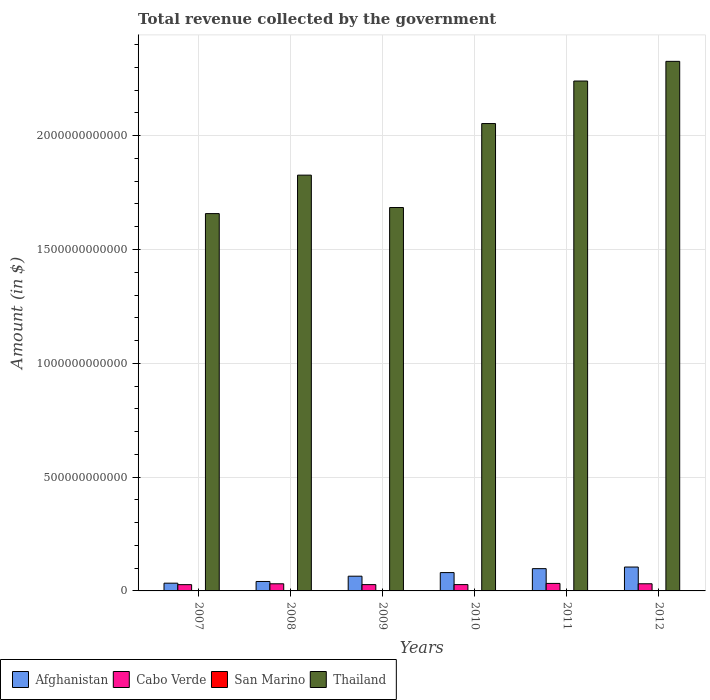How many different coloured bars are there?
Make the answer very short. 4. How many groups of bars are there?
Give a very brief answer. 6. What is the total revenue collected by the government in San Marino in 2008?
Offer a very short reply. 5.91e+08. Across all years, what is the maximum total revenue collected by the government in Thailand?
Give a very brief answer. 2.33e+12. Across all years, what is the minimum total revenue collected by the government in Thailand?
Provide a short and direct response. 1.66e+12. In which year was the total revenue collected by the government in Afghanistan maximum?
Your response must be concise. 2012. What is the total total revenue collected by the government in Thailand in the graph?
Keep it short and to the point. 1.18e+13. What is the difference between the total revenue collected by the government in San Marino in 2007 and that in 2011?
Your response must be concise. 3.65e+07. What is the difference between the total revenue collected by the government in Thailand in 2010 and the total revenue collected by the government in Afghanistan in 2012?
Offer a terse response. 1.95e+12. What is the average total revenue collected by the government in San Marino per year?
Your response must be concise. 5.53e+08. In the year 2012, what is the difference between the total revenue collected by the government in Thailand and total revenue collected by the government in San Marino?
Keep it short and to the point. 2.33e+12. In how many years, is the total revenue collected by the government in San Marino greater than 1000000000000 $?
Make the answer very short. 0. What is the ratio of the total revenue collected by the government in Cabo Verde in 2008 to that in 2012?
Give a very brief answer. 1. Is the total revenue collected by the government in Afghanistan in 2007 less than that in 2008?
Keep it short and to the point. Yes. What is the difference between the highest and the second highest total revenue collected by the government in Cabo Verde?
Provide a succinct answer. 1.59e+09. What is the difference between the highest and the lowest total revenue collected by the government in Cabo Verde?
Provide a short and direct response. 5.41e+09. In how many years, is the total revenue collected by the government in Thailand greater than the average total revenue collected by the government in Thailand taken over all years?
Offer a very short reply. 3. Is it the case that in every year, the sum of the total revenue collected by the government in Afghanistan and total revenue collected by the government in Thailand is greater than the sum of total revenue collected by the government in Cabo Verde and total revenue collected by the government in San Marino?
Your answer should be very brief. Yes. What does the 1st bar from the left in 2007 represents?
Offer a very short reply. Afghanistan. What does the 3rd bar from the right in 2008 represents?
Your answer should be compact. Cabo Verde. Is it the case that in every year, the sum of the total revenue collected by the government in San Marino and total revenue collected by the government in Thailand is greater than the total revenue collected by the government in Afghanistan?
Give a very brief answer. Yes. How many years are there in the graph?
Offer a very short reply. 6. What is the difference between two consecutive major ticks on the Y-axis?
Give a very brief answer. 5.00e+11. Are the values on the major ticks of Y-axis written in scientific E-notation?
Make the answer very short. No. Does the graph contain any zero values?
Ensure brevity in your answer.  No. Does the graph contain grids?
Your answer should be very brief. Yes. How many legend labels are there?
Your response must be concise. 4. How are the legend labels stacked?
Ensure brevity in your answer.  Horizontal. What is the title of the graph?
Make the answer very short. Total revenue collected by the government. What is the label or title of the X-axis?
Give a very brief answer. Years. What is the label or title of the Y-axis?
Offer a very short reply. Amount (in $). What is the Amount (in $) of Afghanistan in 2007?
Your response must be concise. 3.40e+1. What is the Amount (in $) of Cabo Verde in 2007?
Give a very brief answer. 2.75e+1. What is the Amount (in $) of San Marino in 2007?
Your answer should be compact. 5.60e+08. What is the Amount (in $) of Thailand in 2007?
Provide a succinct answer. 1.66e+12. What is the Amount (in $) of Afghanistan in 2008?
Make the answer very short. 4.15e+1. What is the Amount (in $) in Cabo Verde in 2008?
Your answer should be very brief. 3.13e+1. What is the Amount (in $) in San Marino in 2008?
Ensure brevity in your answer.  5.91e+08. What is the Amount (in $) in Thailand in 2008?
Offer a terse response. 1.83e+12. What is the Amount (in $) of Afghanistan in 2009?
Give a very brief answer. 6.47e+1. What is the Amount (in $) in Cabo Verde in 2009?
Offer a terse response. 2.77e+1. What is the Amount (in $) in San Marino in 2009?
Give a very brief answer. 5.62e+08. What is the Amount (in $) of Thailand in 2009?
Make the answer very short. 1.68e+12. What is the Amount (in $) in Afghanistan in 2010?
Keep it short and to the point. 8.06e+1. What is the Amount (in $) in Cabo Verde in 2010?
Offer a terse response. 2.78e+1. What is the Amount (in $) of San Marino in 2010?
Provide a succinct answer. 5.31e+08. What is the Amount (in $) of Thailand in 2010?
Offer a very short reply. 2.05e+12. What is the Amount (in $) of Afghanistan in 2011?
Your answer should be compact. 9.79e+1. What is the Amount (in $) of Cabo Verde in 2011?
Offer a terse response. 3.30e+1. What is the Amount (in $) in San Marino in 2011?
Your response must be concise. 5.23e+08. What is the Amount (in $) in Thailand in 2011?
Your answer should be compact. 2.24e+12. What is the Amount (in $) of Afghanistan in 2012?
Provide a short and direct response. 1.05e+11. What is the Amount (in $) of Cabo Verde in 2012?
Ensure brevity in your answer.  3.14e+1. What is the Amount (in $) of San Marino in 2012?
Your response must be concise. 5.53e+08. What is the Amount (in $) in Thailand in 2012?
Offer a very short reply. 2.33e+12. Across all years, what is the maximum Amount (in $) in Afghanistan?
Ensure brevity in your answer.  1.05e+11. Across all years, what is the maximum Amount (in $) in Cabo Verde?
Provide a short and direct response. 3.30e+1. Across all years, what is the maximum Amount (in $) of San Marino?
Make the answer very short. 5.91e+08. Across all years, what is the maximum Amount (in $) in Thailand?
Your response must be concise. 2.33e+12. Across all years, what is the minimum Amount (in $) in Afghanistan?
Provide a short and direct response. 3.40e+1. Across all years, what is the minimum Amount (in $) of Cabo Verde?
Offer a terse response. 2.75e+1. Across all years, what is the minimum Amount (in $) in San Marino?
Make the answer very short. 5.23e+08. Across all years, what is the minimum Amount (in $) of Thailand?
Provide a short and direct response. 1.66e+12. What is the total Amount (in $) of Afghanistan in the graph?
Provide a succinct answer. 4.24e+11. What is the total Amount (in $) of Cabo Verde in the graph?
Give a very brief answer. 1.79e+11. What is the total Amount (in $) in San Marino in the graph?
Provide a succinct answer. 3.32e+09. What is the total Amount (in $) in Thailand in the graph?
Keep it short and to the point. 1.18e+13. What is the difference between the Amount (in $) of Afghanistan in 2007 and that in 2008?
Provide a succinct answer. -7.45e+09. What is the difference between the Amount (in $) of Cabo Verde in 2007 and that in 2008?
Your answer should be compact. -3.78e+09. What is the difference between the Amount (in $) of San Marino in 2007 and that in 2008?
Give a very brief answer. -3.11e+07. What is the difference between the Amount (in $) of Thailand in 2007 and that in 2008?
Offer a very short reply. -1.69e+11. What is the difference between the Amount (in $) in Afghanistan in 2007 and that in 2009?
Offer a very short reply. -3.07e+1. What is the difference between the Amount (in $) of Cabo Verde in 2007 and that in 2009?
Your answer should be very brief. -1.49e+08. What is the difference between the Amount (in $) of San Marino in 2007 and that in 2009?
Ensure brevity in your answer.  -2.35e+06. What is the difference between the Amount (in $) of Thailand in 2007 and that in 2009?
Provide a short and direct response. -2.67e+1. What is the difference between the Amount (in $) of Afghanistan in 2007 and that in 2010?
Provide a succinct answer. -4.65e+1. What is the difference between the Amount (in $) of Cabo Verde in 2007 and that in 2010?
Provide a short and direct response. -2.30e+08. What is the difference between the Amount (in $) in San Marino in 2007 and that in 2010?
Your response must be concise. 2.91e+07. What is the difference between the Amount (in $) in Thailand in 2007 and that in 2010?
Give a very brief answer. -3.96e+11. What is the difference between the Amount (in $) in Afghanistan in 2007 and that in 2011?
Offer a very short reply. -6.39e+1. What is the difference between the Amount (in $) in Cabo Verde in 2007 and that in 2011?
Ensure brevity in your answer.  -5.41e+09. What is the difference between the Amount (in $) of San Marino in 2007 and that in 2011?
Give a very brief answer. 3.65e+07. What is the difference between the Amount (in $) of Thailand in 2007 and that in 2011?
Your response must be concise. -5.82e+11. What is the difference between the Amount (in $) in Afghanistan in 2007 and that in 2012?
Make the answer very short. -7.09e+1. What is the difference between the Amount (in $) in Cabo Verde in 2007 and that in 2012?
Offer a very short reply. -3.83e+09. What is the difference between the Amount (in $) of San Marino in 2007 and that in 2012?
Keep it short and to the point. 6.55e+06. What is the difference between the Amount (in $) in Thailand in 2007 and that in 2012?
Offer a very short reply. -6.69e+11. What is the difference between the Amount (in $) in Afghanistan in 2008 and that in 2009?
Provide a short and direct response. -2.32e+1. What is the difference between the Amount (in $) in Cabo Verde in 2008 and that in 2009?
Your response must be concise. 3.63e+09. What is the difference between the Amount (in $) in San Marino in 2008 and that in 2009?
Your answer should be compact. 2.87e+07. What is the difference between the Amount (in $) of Thailand in 2008 and that in 2009?
Give a very brief answer. 1.42e+11. What is the difference between the Amount (in $) of Afghanistan in 2008 and that in 2010?
Make the answer very short. -3.91e+1. What is the difference between the Amount (in $) of Cabo Verde in 2008 and that in 2010?
Your answer should be very brief. 3.55e+09. What is the difference between the Amount (in $) in San Marino in 2008 and that in 2010?
Offer a very short reply. 6.02e+07. What is the difference between the Amount (in $) in Thailand in 2008 and that in 2010?
Your response must be concise. -2.27e+11. What is the difference between the Amount (in $) in Afghanistan in 2008 and that in 2011?
Your response must be concise. -5.64e+1. What is the difference between the Amount (in $) in Cabo Verde in 2008 and that in 2011?
Offer a terse response. -1.63e+09. What is the difference between the Amount (in $) of San Marino in 2008 and that in 2011?
Your answer should be very brief. 6.76e+07. What is the difference between the Amount (in $) in Thailand in 2008 and that in 2011?
Make the answer very short. -4.13e+11. What is the difference between the Amount (in $) in Afghanistan in 2008 and that in 2012?
Offer a terse response. -6.35e+1. What is the difference between the Amount (in $) of Cabo Verde in 2008 and that in 2012?
Your answer should be compact. -4.40e+07. What is the difference between the Amount (in $) of San Marino in 2008 and that in 2012?
Offer a very short reply. 3.76e+07. What is the difference between the Amount (in $) in Thailand in 2008 and that in 2012?
Your answer should be compact. -5.00e+11. What is the difference between the Amount (in $) of Afghanistan in 2009 and that in 2010?
Your answer should be very brief. -1.59e+1. What is the difference between the Amount (in $) in Cabo Verde in 2009 and that in 2010?
Your answer should be very brief. -8.03e+07. What is the difference between the Amount (in $) in San Marino in 2009 and that in 2010?
Offer a terse response. 3.15e+07. What is the difference between the Amount (in $) in Thailand in 2009 and that in 2010?
Provide a short and direct response. -3.69e+11. What is the difference between the Amount (in $) in Afghanistan in 2009 and that in 2011?
Your answer should be compact. -3.32e+1. What is the difference between the Amount (in $) of Cabo Verde in 2009 and that in 2011?
Give a very brief answer. -5.26e+09. What is the difference between the Amount (in $) of San Marino in 2009 and that in 2011?
Your answer should be compact. 3.89e+07. What is the difference between the Amount (in $) in Thailand in 2009 and that in 2011?
Provide a short and direct response. -5.56e+11. What is the difference between the Amount (in $) in Afghanistan in 2009 and that in 2012?
Offer a very short reply. -4.03e+1. What is the difference between the Amount (in $) of Cabo Verde in 2009 and that in 2012?
Provide a succinct answer. -3.68e+09. What is the difference between the Amount (in $) of San Marino in 2009 and that in 2012?
Your answer should be compact. 8.90e+06. What is the difference between the Amount (in $) of Thailand in 2009 and that in 2012?
Give a very brief answer. -6.42e+11. What is the difference between the Amount (in $) in Afghanistan in 2010 and that in 2011?
Give a very brief answer. -1.73e+1. What is the difference between the Amount (in $) of Cabo Verde in 2010 and that in 2011?
Your answer should be very brief. -5.18e+09. What is the difference between the Amount (in $) in San Marino in 2010 and that in 2011?
Your answer should be compact. 7.36e+06. What is the difference between the Amount (in $) in Thailand in 2010 and that in 2011?
Keep it short and to the point. -1.87e+11. What is the difference between the Amount (in $) of Afghanistan in 2010 and that in 2012?
Offer a terse response. -2.44e+1. What is the difference between the Amount (in $) in Cabo Verde in 2010 and that in 2012?
Ensure brevity in your answer.  -3.60e+09. What is the difference between the Amount (in $) in San Marino in 2010 and that in 2012?
Your answer should be very brief. -2.26e+07. What is the difference between the Amount (in $) in Thailand in 2010 and that in 2012?
Your answer should be very brief. -2.73e+11. What is the difference between the Amount (in $) of Afghanistan in 2011 and that in 2012?
Offer a terse response. -7.07e+09. What is the difference between the Amount (in $) in Cabo Verde in 2011 and that in 2012?
Give a very brief answer. 1.59e+09. What is the difference between the Amount (in $) of San Marino in 2011 and that in 2012?
Give a very brief answer. -3.00e+07. What is the difference between the Amount (in $) in Thailand in 2011 and that in 2012?
Your answer should be very brief. -8.64e+1. What is the difference between the Amount (in $) in Afghanistan in 2007 and the Amount (in $) in Cabo Verde in 2008?
Offer a terse response. 2.70e+09. What is the difference between the Amount (in $) in Afghanistan in 2007 and the Amount (in $) in San Marino in 2008?
Offer a terse response. 3.34e+1. What is the difference between the Amount (in $) in Afghanistan in 2007 and the Amount (in $) in Thailand in 2008?
Make the answer very short. -1.79e+12. What is the difference between the Amount (in $) of Cabo Verde in 2007 and the Amount (in $) of San Marino in 2008?
Your answer should be compact. 2.70e+1. What is the difference between the Amount (in $) of Cabo Verde in 2007 and the Amount (in $) of Thailand in 2008?
Provide a succinct answer. -1.80e+12. What is the difference between the Amount (in $) in San Marino in 2007 and the Amount (in $) in Thailand in 2008?
Offer a terse response. -1.83e+12. What is the difference between the Amount (in $) of Afghanistan in 2007 and the Amount (in $) of Cabo Verde in 2009?
Your answer should be very brief. 6.33e+09. What is the difference between the Amount (in $) of Afghanistan in 2007 and the Amount (in $) of San Marino in 2009?
Offer a terse response. 3.35e+1. What is the difference between the Amount (in $) of Afghanistan in 2007 and the Amount (in $) of Thailand in 2009?
Your answer should be very brief. -1.65e+12. What is the difference between the Amount (in $) of Cabo Verde in 2007 and the Amount (in $) of San Marino in 2009?
Offer a terse response. 2.70e+1. What is the difference between the Amount (in $) in Cabo Verde in 2007 and the Amount (in $) in Thailand in 2009?
Your answer should be very brief. -1.66e+12. What is the difference between the Amount (in $) of San Marino in 2007 and the Amount (in $) of Thailand in 2009?
Provide a succinct answer. -1.68e+12. What is the difference between the Amount (in $) of Afghanistan in 2007 and the Amount (in $) of Cabo Verde in 2010?
Offer a very short reply. 6.25e+09. What is the difference between the Amount (in $) of Afghanistan in 2007 and the Amount (in $) of San Marino in 2010?
Your answer should be compact. 3.35e+1. What is the difference between the Amount (in $) of Afghanistan in 2007 and the Amount (in $) of Thailand in 2010?
Your response must be concise. -2.02e+12. What is the difference between the Amount (in $) of Cabo Verde in 2007 and the Amount (in $) of San Marino in 2010?
Give a very brief answer. 2.70e+1. What is the difference between the Amount (in $) in Cabo Verde in 2007 and the Amount (in $) in Thailand in 2010?
Offer a terse response. -2.03e+12. What is the difference between the Amount (in $) in San Marino in 2007 and the Amount (in $) in Thailand in 2010?
Offer a terse response. -2.05e+12. What is the difference between the Amount (in $) of Afghanistan in 2007 and the Amount (in $) of Cabo Verde in 2011?
Your answer should be very brief. 1.07e+09. What is the difference between the Amount (in $) in Afghanistan in 2007 and the Amount (in $) in San Marino in 2011?
Give a very brief answer. 3.35e+1. What is the difference between the Amount (in $) of Afghanistan in 2007 and the Amount (in $) of Thailand in 2011?
Your answer should be very brief. -2.21e+12. What is the difference between the Amount (in $) of Cabo Verde in 2007 and the Amount (in $) of San Marino in 2011?
Offer a terse response. 2.70e+1. What is the difference between the Amount (in $) of Cabo Verde in 2007 and the Amount (in $) of Thailand in 2011?
Provide a short and direct response. -2.21e+12. What is the difference between the Amount (in $) of San Marino in 2007 and the Amount (in $) of Thailand in 2011?
Your response must be concise. -2.24e+12. What is the difference between the Amount (in $) in Afghanistan in 2007 and the Amount (in $) in Cabo Verde in 2012?
Provide a succinct answer. 2.65e+09. What is the difference between the Amount (in $) in Afghanistan in 2007 and the Amount (in $) in San Marino in 2012?
Keep it short and to the point. 3.35e+1. What is the difference between the Amount (in $) in Afghanistan in 2007 and the Amount (in $) in Thailand in 2012?
Offer a terse response. -2.29e+12. What is the difference between the Amount (in $) of Cabo Verde in 2007 and the Amount (in $) of San Marino in 2012?
Your answer should be very brief. 2.70e+1. What is the difference between the Amount (in $) in Cabo Verde in 2007 and the Amount (in $) in Thailand in 2012?
Provide a short and direct response. -2.30e+12. What is the difference between the Amount (in $) in San Marino in 2007 and the Amount (in $) in Thailand in 2012?
Keep it short and to the point. -2.33e+12. What is the difference between the Amount (in $) in Afghanistan in 2008 and the Amount (in $) in Cabo Verde in 2009?
Make the answer very short. 1.38e+1. What is the difference between the Amount (in $) in Afghanistan in 2008 and the Amount (in $) in San Marino in 2009?
Your answer should be very brief. 4.09e+1. What is the difference between the Amount (in $) of Afghanistan in 2008 and the Amount (in $) of Thailand in 2009?
Ensure brevity in your answer.  -1.64e+12. What is the difference between the Amount (in $) in Cabo Verde in 2008 and the Amount (in $) in San Marino in 2009?
Provide a short and direct response. 3.08e+1. What is the difference between the Amount (in $) of Cabo Verde in 2008 and the Amount (in $) of Thailand in 2009?
Keep it short and to the point. -1.65e+12. What is the difference between the Amount (in $) in San Marino in 2008 and the Amount (in $) in Thailand in 2009?
Your answer should be compact. -1.68e+12. What is the difference between the Amount (in $) of Afghanistan in 2008 and the Amount (in $) of Cabo Verde in 2010?
Give a very brief answer. 1.37e+1. What is the difference between the Amount (in $) in Afghanistan in 2008 and the Amount (in $) in San Marino in 2010?
Keep it short and to the point. 4.09e+1. What is the difference between the Amount (in $) of Afghanistan in 2008 and the Amount (in $) of Thailand in 2010?
Provide a short and direct response. -2.01e+12. What is the difference between the Amount (in $) in Cabo Verde in 2008 and the Amount (in $) in San Marino in 2010?
Your answer should be compact. 3.08e+1. What is the difference between the Amount (in $) in Cabo Verde in 2008 and the Amount (in $) in Thailand in 2010?
Make the answer very short. -2.02e+12. What is the difference between the Amount (in $) in San Marino in 2008 and the Amount (in $) in Thailand in 2010?
Your answer should be compact. -2.05e+12. What is the difference between the Amount (in $) of Afghanistan in 2008 and the Amount (in $) of Cabo Verde in 2011?
Provide a succinct answer. 8.52e+09. What is the difference between the Amount (in $) of Afghanistan in 2008 and the Amount (in $) of San Marino in 2011?
Provide a succinct answer. 4.10e+1. What is the difference between the Amount (in $) in Afghanistan in 2008 and the Amount (in $) in Thailand in 2011?
Offer a terse response. -2.20e+12. What is the difference between the Amount (in $) in Cabo Verde in 2008 and the Amount (in $) in San Marino in 2011?
Give a very brief answer. 3.08e+1. What is the difference between the Amount (in $) of Cabo Verde in 2008 and the Amount (in $) of Thailand in 2011?
Offer a very short reply. -2.21e+12. What is the difference between the Amount (in $) of San Marino in 2008 and the Amount (in $) of Thailand in 2011?
Offer a very short reply. -2.24e+12. What is the difference between the Amount (in $) of Afghanistan in 2008 and the Amount (in $) of Cabo Verde in 2012?
Offer a very short reply. 1.01e+1. What is the difference between the Amount (in $) of Afghanistan in 2008 and the Amount (in $) of San Marino in 2012?
Offer a very short reply. 4.09e+1. What is the difference between the Amount (in $) of Afghanistan in 2008 and the Amount (in $) of Thailand in 2012?
Your answer should be very brief. -2.29e+12. What is the difference between the Amount (in $) of Cabo Verde in 2008 and the Amount (in $) of San Marino in 2012?
Ensure brevity in your answer.  3.08e+1. What is the difference between the Amount (in $) in Cabo Verde in 2008 and the Amount (in $) in Thailand in 2012?
Ensure brevity in your answer.  -2.30e+12. What is the difference between the Amount (in $) of San Marino in 2008 and the Amount (in $) of Thailand in 2012?
Your response must be concise. -2.33e+12. What is the difference between the Amount (in $) in Afghanistan in 2009 and the Amount (in $) in Cabo Verde in 2010?
Give a very brief answer. 3.69e+1. What is the difference between the Amount (in $) in Afghanistan in 2009 and the Amount (in $) in San Marino in 2010?
Your answer should be compact. 6.42e+1. What is the difference between the Amount (in $) of Afghanistan in 2009 and the Amount (in $) of Thailand in 2010?
Ensure brevity in your answer.  -1.99e+12. What is the difference between the Amount (in $) of Cabo Verde in 2009 and the Amount (in $) of San Marino in 2010?
Your answer should be compact. 2.72e+1. What is the difference between the Amount (in $) in Cabo Verde in 2009 and the Amount (in $) in Thailand in 2010?
Give a very brief answer. -2.03e+12. What is the difference between the Amount (in $) in San Marino in 2009 and the Amount (in $) in Thailand in 2010?
Give a very brief answer. -2.05e+12. What is the difference between the Amount (in $) of Afghanistan in 2009 and the Amount (in $) of Cabo Verde in 2011?
Keep it short and to the point. 3.17e+1. What is the difference between the Amount (in $) in Afghanistan in 2009 and the Amount (in $) in San Marino in 2011?
Your answer should be compact. 6.42e+1. What is the difference between the Amount (in $) in Afghanistan in 2009 and the Amount (in $) in Thailand in 2011?
Keep it short and to the point. -2.18e+12. What is the difference between the Amount (in $) in Cabo Verde in 2009 and the Amount (in $) in San Marino in 2011?
Provide a succinct answer. 2.72e+1. What is the difference between the Amount (in $) in Cabo Verde in 2009 and the Amount (in $) in Thailand in 2011?
Provide a succinct answer. -2.21e+12. What is the difference between the Amount (in $) of San Marino in 2009 and the Amount (in $) of Thailand in 2011?
Ensure brevity in your answer.  -2.24e+12. What is the difference between the Amount (in $) of Afghanistan in 2009 and the Amount (in $) of Cabo Verde in 2012?
Keep it short and to the point. 3.33e+1. What is the difference between the Amount (in $) in Afghanistan in 2009 and the Amount (in $) in San Marino in 2012?
Offer a terse response. 6.41e+1. What is the difference between the Amount (in $) in Afghanistan in 2009 and the Amount (in $) in Thailand in 2012?
Your answer should be compact. -2.26e+12. What is the difference between the Amount (in $) of Cabo Verde in 2009 and the Amount (in $) of San Marino in 2012?
Give a very brief answer. 2.71e+1. What is the difference between the Amount (in $) in Cabo Verde in 2009 and the Amount (in $) in Thailand in 2012?
Keep it short and to the point. -2.30e+12. What is the difference between the Amount (in $) in San Marino in 2009 and the Amount (in $) in Thailand in 2012?
Your answer should be compact. -2.33e+12. What is the difference between the Amount (in $) of Afghanistan in 2010 and the Amount (in $) of Cabo Verde in 2011?
Your answer should be compact. 4.76e+1. What is the difference between the Amount (in $) in Afghanistan in 2010 and the Amount (in $) in San Marino in 2011?
Make the answer very short. 8.00e+1. What is the difference between the Amount (in $) in Afghanistan in 2010 and the Amount (in $) in Thailand in 2011?
Offer a terse response. -2.16e+12. What is the difference between the Amount (in $) of Cabo Verde in 2010 and the Amount (in $) of San Marino in 2011?
Ensure brevity in your answer.  2.72e+1. What is the difference between the Amount (in $) in Cabo Verde in 2010 and the Amount (in $) in Thailand in 2011?
Make the answer very short. -2.21e+12. What is the difference between the Amount (in $) of San Marino in 2010 and the Amount (in $) of Thailand in 2011?
Provide a succinct answer. -2.24e+12. What is the difference between the Amount (in $) in Afghanistan in 2010 and the Amount (in $) in Cabo Verde in 2012?
Your answer should be very brief. 4.92e+1. What is the difference between the Amount (in $) of Afghanistan in 2010 and the Amount (in $) of San Marino in 2012?
Provide a succinct answer. 8.00e+1. What is the difference between the Amount (in $) in Afghanistan in 2010 and the Amount (in $) in Thailand in 2012?
Ensure brevity in your answer.  -2.25e+12. What is the difference between the Amount (in $) of Cabo Verde in 2010 and the Amount (in $) of San Marino in 2012?
Keep it short and to the point. 2.72e+1. What is the difference between the Amount (in $) in Cabo Verde in 2010 and the Amount (in $) in Thailand in 2012?
Your response must be concise. -2.30e+12. What is the difference between the Amount (in $) of San Marino in 2010 and the Amount (in $) of Thailand in 2012?
Your answer should be compact. -2.33e+12. What is the difference between the Amount (in $) in Afghanistan in 2011 and the Amount (in $) in Cabo Verde in 2012?
Provide a short and direct response. 6.65e+1. What is the difference between the Amount (in $) in Afghanistan in 2011 and the Amount (in $) in San Marino in 2012?
Keep it short and to the point. 9.73e+1. What is the difference between the Amount (in $) in Afghanistan in 2011 and the Amount (in $) in Thailand in 2012?
Your answer should be compact. -2.23e+12. What is the difference between the Amount (in $) of Cabo Verde in 2011 and the Amount (in $) of San Marino in 2012?
Your answer should be very brief. 3.24e+1. What is the difference between the Amount (in $) in Cabo Verde in 2011 and the Amount (in $) in Thailand in 2012?
Offer a very short reply. -2.29e+12. What is the difference between the Amount (in $) in San Marino in 2011 and the Amount (in $) in Thailand in 2012?
Offer a very short reply. -2.33e+12. What is the average Amount (in $) of Afghanistan per year?
Your answer should be compact. 7.06e+1. What is the average Amount (in $) in Cabo Verde per year?
Your answer should be compact. 2.98e+1. What is the average Amount (in $) in San Marino per year?
Provide a succinct answer. 5.53e+08. What is the average Amount (in $) in Thailand per year?
Give a very brief answer. 1.96e+12. In the year 2007, what is the difference between the Amount (in $) of Afghanistan and Amount (in $) of Cabo Verde?
Give a very brief answer. 6.48e+09. In the year 2007, what is the difference between the Amount (in $) in Afghanistan and Amount (in $) in San Marino?
Ensure brevity in your answer.  3.35e+1. In the year 2007, what is the difference between the Amount (in $) of Afghanistan and Amount (in $) of Thailand?
Your answer should be very brief. -1.62e+12. In the year 2007, what is the difference between the Amount (in $) of Cabo Verde and Amount (in $) of San Marino?
Make the answer very short. 2.70e+1. In the year 2007, what is the difference between the Amount (in $) of Cabo Verde and Amount (in $) of Thailand?
Ensure brevity in your answer.  -1.63e+12. In the year 2007, what is the difference between the Amount (in $) in San Marino and Amount (in $) in Thailand?
Ensure brevity in your answer.  -1.66e+12. In the year 2008, what is the difference between the Amount (in $) in Afghanistan and Amount (in $) in Cabo Verde?
Your response must be concise. 1.01e+1. In the year 2008, what is the difference between the Amount (in $) in Afghanistan and Amount (in $) in San Marino?
Your answer should be compact. 4.09e+1. In the year 2008, what is the difference between the Amount (in $) of Afghanistan and Amount (in $) of Thailand?
Your response must be concise. -1.79e+12. In the year 2008, what is the difference between the Amount (in $) of Cabo Verde and Amount (in $) of San Marino?
Ensure brevity in your answer.  3.07e+1. In the year 2008, what is the difference between the Amount (in $) in Cabo Verde and Amount (in $) in Thailand?
Your response must be concise. -1.80e+12. In the year 2008, what is the difference between the Amount (in $) in San Marino and Amount (in $) in Thailand?
Keep it short and to the point. -1.83e+12. In the year 2009, what is the difference between the Amount (in $) of Afghanistan and Amount (in $) of Cabo Verde?
Your answer should be compact. 3.70e+1. In the year 2009, what is the difference between the Amount (in $) in Afghanistan and Amount (in $) in San Marino?
Offer a very short reply. 6.41e+1. In the year 2009, what is the difference between the Amount (in $) in Afghanistan and Amount (in $) in Thailand?
Provide a short and direct response. -1.62e+12. In the year 2009, what is the difference between the Amount (in $) of Cabo Verde and Amount (in $) of San Marino?
Give a very brief answer. 2.71e+1. In the year 2009, what is the difference between the Amount (in $) in Cabo Verde and Amount (in $) in Thailand?
Provide a short and direct response. -1.66e+12. In the year 2009, what is the difference between the Amount (in $) in San Marino and Amount (in $) in Thailand?
Give a very brief answer. -1.68e+12. In the year 2010, what is the difference between the Amount (in $) of Afghanistan and Amount (in $) of Cabo Verde?
Give a very brief answer. 5.28e+1. In the year 2010, what is the difference between the Amount (in $) in Afghanistan and Amount (in $) in San Marino?
Provide a succinct answer. 8.00e+1. In the year 2010, what is the difference between the Amount (in $) in Afghanistan and Amount (in $) in Thailand?
Give a very brief answer. -1.97e+12. In the year 2010, what is the difference between the Amount (in $) of Cabo Verde and Amount (in $) of San Marino?
Ensure brevity in your answer.  2.72e+1. In the year 2010, what is the difference between the Amount (in $) of Cabo Verde and Amount (in $) of Thailand?
Ensure brevity in your answer.  -2.03e+12. In the year 2010, what is the difference between the Amount (in $) in San Marino and Amount (in $) in Thailand?
Your response must be concise. -2.05e+12. In the year 2011, what is the difference between the Amount (in $) in Afghanistan and Amount (in $) in Cabo Verde?
Give a very brief answer. 6.49e+1. In the year 2011, what is the difference between the Amount (in $) of Afghanistan and Amount (in $) of San Marino?
Your response must be concise. 9.74e+1. In the year 2011, what is the difference between the Amount (in $) of Afghanistan and Amount (in $) of Thailand?
Make the answer very short. -2.14e+12. In the year 2011, what is the difference between the Amount (in $) of Cabo Verde and Amount (in $) of San Marino?
Provide a short and direct response. 3.24e+1. In the year 2011, what is the difference between the Amount (in $) in Cabo Verde and Amount (in $) in Thailand?
Your answer should be compact. -2.21e+12. In the year 2011, what is the difference between the Amount (in $) in San Marino and Amount (in $) in Thailand?
Provide a succinct answer. -2.24e+12. In the year 2012, what is the difference between the Amount (in $) of Afghanistan and Amount (in $) of Cabo Verde?
Provide a succinct answer. 7.36e+1. In the year 2012, what is the difference between the Amount (in $) in Afghanistan and Amount (in $) in San Marino?
Offer a terse response. 1.04e+11. In the year 2012, what is the difference between the Amount (in $) of Afghanistan and Amount (in $) of Thailand?
Give a very brief answer. -2.22e+12. In the year 2012, what is the difference between the Amount (in $) of Cabo Verde and Amount (in $) of San Marino?
Give a very brief answer. 3.08e+1. In the year 2012, what is the difference between the Amount (in $) in Cabo Verde and Amount (in $) in Thailand?
Give a very brief answer. -2.30e+12. In the year 2012, what is the difference between the Amount (in $) of San Marino and Amount (in $) of Thailand?
Make the answer very short. -2.33e+12. What is the ratio of the Amount (in $) in Afghanistan in 2007 to that in 2008?
Your response must be concise. 0.82. What is the ratio of the Amount (in $) in Cabo Verde in 2007 to that in 2008?
Give a very brief answer. 0.88. What is the ratio of the Amount (in $) of Thailand in 2007 to that in 2008?
Make the answer very short. 0.91. What is the ratio of the Amount (in $) in Afghanistan in 2007 to that in 2009?
Give a very brief answer. 0.53. What is the ratio of the Amount (in $) in San Marino in 2007 to that in 2009?
Your answer should be compact. 1. What is the ratio of the Amount (in $) in Thailand in 2007 to that in 2009?
Keep it short and to the point. 0.98. What is the ratio of the Amount (in $) in Afghanistan in 2007 to that in 2010?
Provide a succinct answer. 0.42. What is the ratio of the Amount (in $) of Cabo Verde in 2007 to that in 2010?
Provide a short and direct response. 0.99. What is the ratio of the Amount (in $) in San Marino in 2007 to that in 2010?
Your answer should be compact. 1.05. What is the ratio of the Amount (in $) of Thailand in 2007 to that in 2010?
Keep it short and to the point. 0.81. What is the ratio of the Amount (in $) in Afghanistan in 2007 to that in 2011?
Offer a very short reply. 0.35. What is the ratio of the Amount (in $) in Cabo Verde in 2007 to that in 2011?
Your answer should be very brief. 0.84. What is the ratio of the Amount (in $) in San Marino in 2007 to that in 2011?
Keep it short and to the point. 1.07. What is the ratio of the Amount (in $) of Thailand in 2007 to that in 2011?
Ensure brevity in your answer.  0.74. What is the ratio of the Amount (in $) in Afghanistan in 2007 to that in 2012?
Your response must be concise. 0.32. What is the ratio of the Amount (in $) of Cabo Verde in 2007 to that in 2012?
Keep it short and to the point. 0.88. What is the ratio of the Amount (in $) of San Marino in 2007 to that in 2012?
Your response must be concise. 1.01. What is the ratio of the Amount (in $) in Thailand in 2007 to that in 2012?
Ensure brevity in your answer.  0.71. What is the ratio of the Amount (in $) in Afghanistan in 2008 to that in 2009?
Your answer should be very brief. 0.64. What is the ratio of the Amount (in $) in Cabo Verde in 2008 to that in 2009?
Your answer should be very brief. 1.13. What is the ratio of the Amount (in $) of San Marino in 2008 to that in 2009?
Ensure brevity in your answer.  1.05. What is the ratio of the Amount (in $) in Thailand in 2008 to that in 2009?
Provide a short and direct response. 1.08. What is the ratio of the Amount (in $) in Afghanistan in 2008 to that in 2010?
Your answer should be compact. 0.51. What is the ratio of the Amount (in $) of Cabo Verde in 2008 to that in 2010?
Offer a terse response. 1.13. What is the ratio of the Amount (in $) in San Marino in 2008 to that in 2010?
Keep it short and to the point. 1.11. What is the ratio of the Amount (in $) of Thailand in 2008 to that in 2010?
Give a very brief answer. 0.89. What is the ratio of the Amount (in $) of Afghanistan in 2008 to that in 2011?
Make the answer very short. 0.42. What is the ratio of the Amount (in $) in Cabo Verde in 2008 to that in 2011?
Provide a succinct answer. 0.95. What is the ratio of the Amount (in $) of San Marino in 2008 to that in 2011?
Provide a short and direct response. 1.13. What is the ratio of the Amount (in $) in Thailand in 2008 to that in 2011?
Your response must be concise. 0.82. What is the ratio of the Amount (in $) of Afghanistan in 2008 to that in 2012?
Your answer should be very brief. 0.4. What is the ratio of the Amount (in $) in Cabo Verde in 2008 to that in 2012?
Make the answer very short. 1. What is the ratio of the Amount (in $) of San Marino in 2008 to that in 2012?
Your answer should be compact. 1.07. What is the ratio of the Amount (in $) in Thailand in 2008 to that in 2012?
Provide a short and direct response. 0.79. What is the ratio of the Amount (in $) in Afghanistan in 2009 to that in 2010?
Your answer should be compact. 0.8. What is the ratio of the Amount (in $) in San Marino in 2009 to that in 2010?
Provide a succinct answer. 1.06. What is the ratio of the Amount (in $) of Thailand in 2009 to that in 2010?
Your answer should be compact. 0.82. What is the ratio of the Amount (in $) of Afghanistan in 2009 to that in 2011?
Your answer should be compact. 0.66. What is the ratio of the Amount (in $) of Cabo Verde in 2009 to that in 2011?
Your answer should be compact. 0.84. What is the ratio of the Amount (in $) in San Marino in 2009 to that in 2011?
Your answer should be very brief. 1.07. What is the ratio of the Amount (in $) in Thailand in 2009 to that in 2011?
Provide a succinct answer. 0.75. What is the ratio of the Amount (in $) of Afghanistan in 2009 to that in 2012?
Your answer should be very brief. 0.62. What is the ratio of the Amount (in $) in Cabo Verde in 2009 to that in 2012?
Provide a succinct answer. 0.88. What is the ratio of the Amount (in $) of San Marino in 2009 to that in 2012?
Offer a terse response. 1.02. What is the ratio of the Amount (in $) in Thailand in 2009 to that in 2012?
Provide a short and direct response. 0.72. What is the ratio of the Amount (in $) of Afghanistan in 2010 to that in 2011?
Ensure brevity in your answer.  0.82. What is the ratio of the Amount (in $) of Cabo Verde in 2010 to that in 2011?
Ensure brevity in your answer.  0.84. What is the ratio of the Amount (in $) in San Marino in 2010 to that in 2011?
Offer a very short reply. 1.01. What is the ratio of the Amount (in $) in Thailand in 2010 to that in 2011?
Make the answer very short. 0.92. What is the ratio of the Amount (in $) in Afghanistan in 2010 to that in 2012?
Offer a very short reply. 0.77. What is the ratio of the Amount (in $) of Cabo Verde in 2010 to that in 2012?
Your response must be concise. 0.89. What is the ratio of the Amount (in $) of San Marino in 2010 to that in 2012?
Your answer should be compact. 0.96. What is the ratio of the Amount (in $) of Thailand in 2010 to that in 2012?
Your answer should be very brief. 0.88. What is the ratio of the Amount (in $) in Afghanistan in 2011 to that in 2012?
Your answer should be compact. 0.93. What is the ratio of the Amount (in $) in Cabo Verde in 2011 to that in 2012?
Your answer should be compact. 1.05. What is the ratio of the Amount (in $) in San Marino in 2011 to that in 2012?
Offer a very short reply. 0.95. What is the ratio of the Amount (in $) in Thailand in 2011 to that in 2012?
Make the answer very short. 0.96. What is the difference between the highest and the second highest Amount (in $) of Afghanistan?
Provide a short and direct response. 7.07e+09. What is the difference between the highest and the second highest Amount (in $) in Cabo Verde?
Your response must be concise. 1.59e+09. What is the difference between the highest and the second highest Amount (in $) of San Marino?
Offer a terse response. 2.87e+07. What is the difference between the highest and the second highest Amount (in $) of Thailand?
Provide a succinct answer. 8.64e+1. What is the difference between the highest and the lowest Amount (in $) in Afghanistan?
Provide a short and direct response. 7.09e+1. What is the difference between the highest and the lowest Amount (in $) in Cabo Verde?
Make the answer very short. 5.41e+09. What is the difference between the highest and the lowest Amount (in $) in San Marino?
Offer a very short reply. 6.76e+07. What is the difference between the highest and the lowest Amount (in $) in Thailand?
Your answer should be compact. 6.69e+11. 